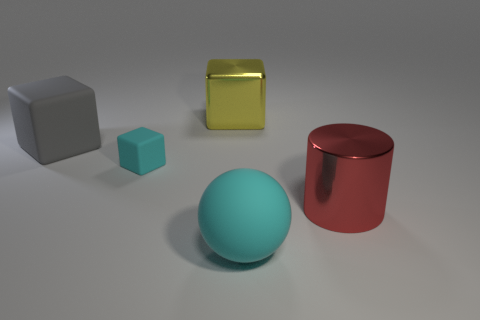Can you describe the lighting and shadows in this scene? Certainly! The scene is lit with a soft, diffused light source, resulting in gentle shadows beneath each object. The direction of the light appears to be coming from the top left, as seen by the location of the shadows. This creates a calm and even illumination across the scene, highlighting the textures and colors of the objects without harsh contrasts. Does the lighting tell us anything about the texture of the objects? Absolutely. The way the light interacts with the objects suggests their surfaces have different textures. The matte objects, like the gray and turquoise cubes, diffuse the light evenly, indicating a rougher surface. In contrast, the red metallic cylinder has a glossy finish, reflecting the light more sharply and revealing its smooth texture. 